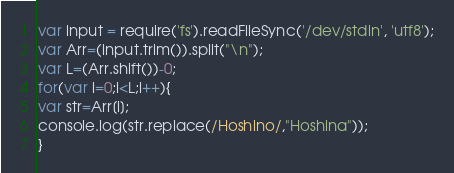Convert code to text. <code><loc_0><loc_0><loc_500><loc_500><_JavaScript_>var input = require('fs').readFileSync('/dev/stdin', 'utf8');
var Arr=(input.trim()).split("\n");
var L=(Arr.shift())-0;
for(var i=0;i<L;i++){
var str=Arr[i];
console.log(str.replace(/Hoshino/,"Hoshina"));
}</code> 